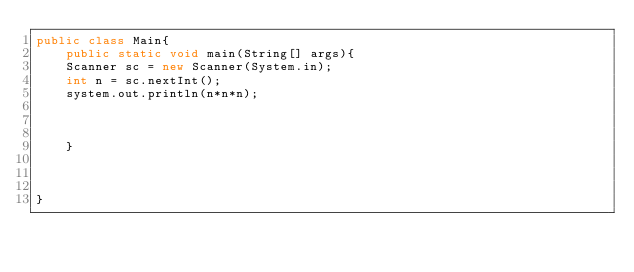Convert code to text. <code><loc_0><loc_0><loc_500><loc_500><_Java_>public class Main{
	public static void main(String[] args){
    Scanner sc = new Scanner(System.in);
    int n = sc.nextInt();
    system.out.println(n*n*n);
    
    
    
    }



}</code> 